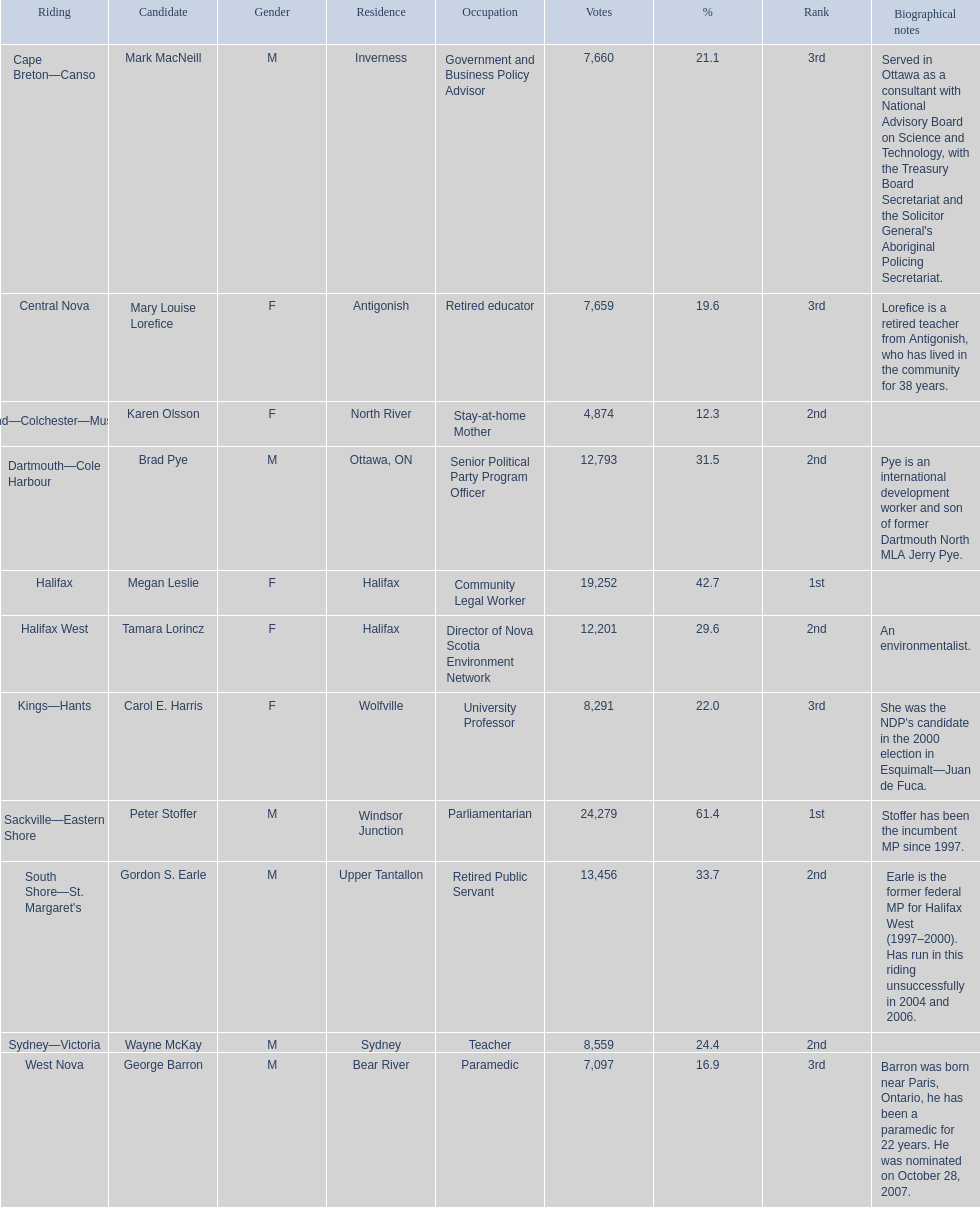Who are the various contenders? Mark MacNeill, Mary Louise Lorefice, Karen Olsson, Brad Pye, Megan Leslie, Tamara Lorincz, Carol E. Harris, Peter Stoffer, Gordon S. Earle, Wayne McKay, George Barron. What is the vote count for each? 7,660, 7,659, 4,874, 12,793, 19,252, 12,201, 8,291, 24,279, 13,456, 8,559, 7,097. Additionally, what portion of those votes were cast for megan leslie? 19,252. 